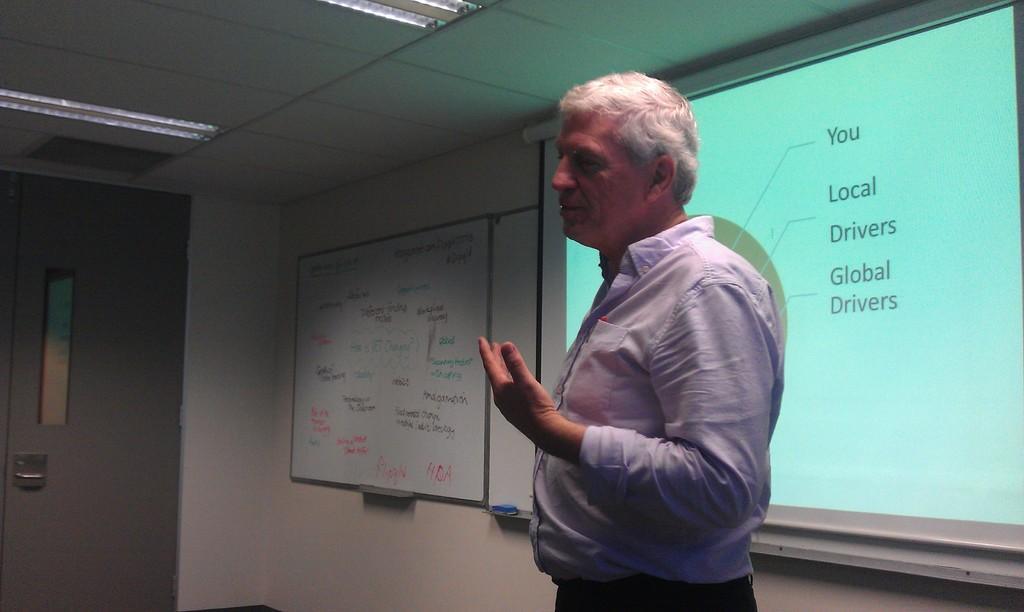How would you summarize this image in a sentence or two? In this picture we can see a man, behind to him we can see a projector screen and a board on the wall, and also we can find lights. 